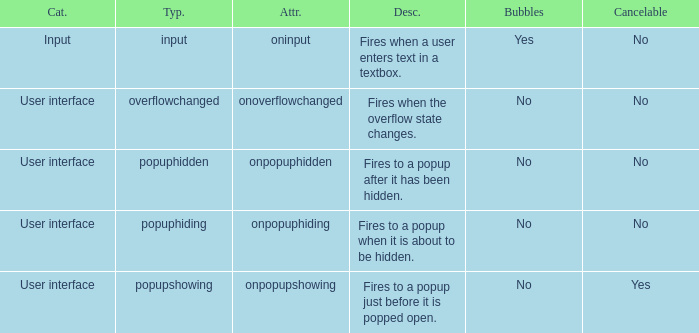What's the attribute with cancelable being yes Onpopupshowing. 